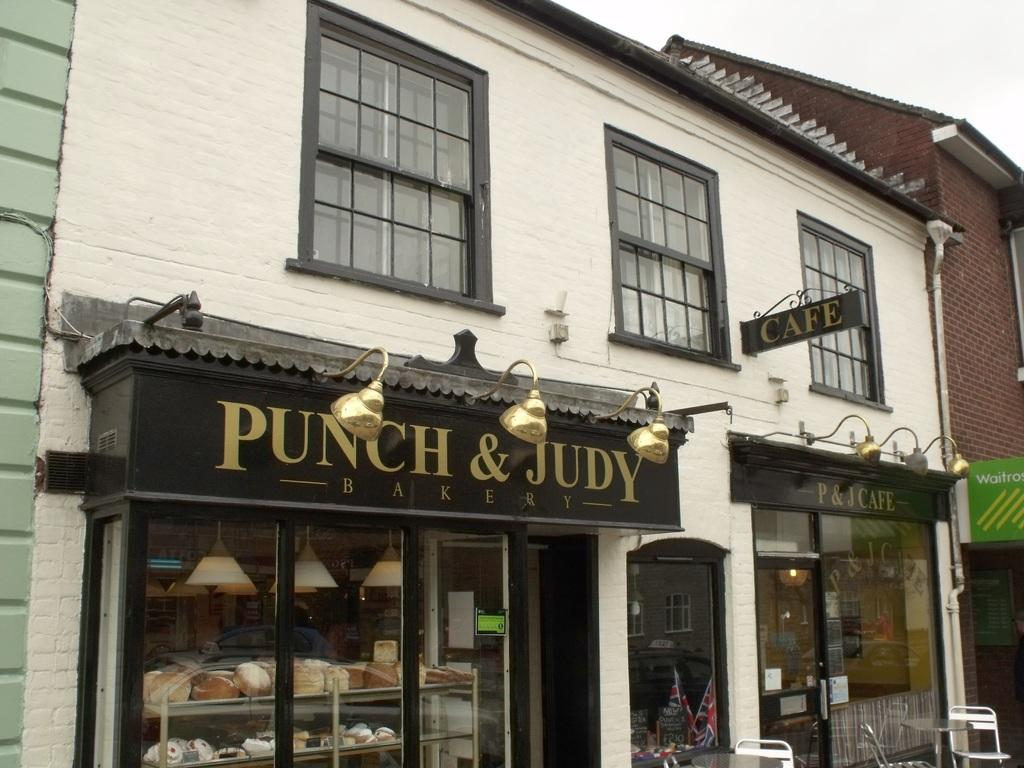What type of establishment is depicted in the image? There is a store in the image. What material is used for the wall and door in the image? The wall and door in the image are made of glass. What is the large sign in the image called? There is a hoarding in the image. What is the small sign with the name of the store called? There is a name plate in the image. What other glass features can be seen in the image? There are glass windows in the image. What type of crayon design can be seen on the glass door in the image? There is no crayon design present on the glass door in the image. 